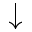<formula> <loc_0><loc_0><loc_500><loc_500>\downarrow</formula> 